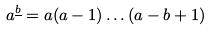<formula> <loc_0><loc_0><loc_500><loc_500>a ^ { \underline { b } } = a ( a - 1 ) \dots ( a - b + 1 )</formula> 